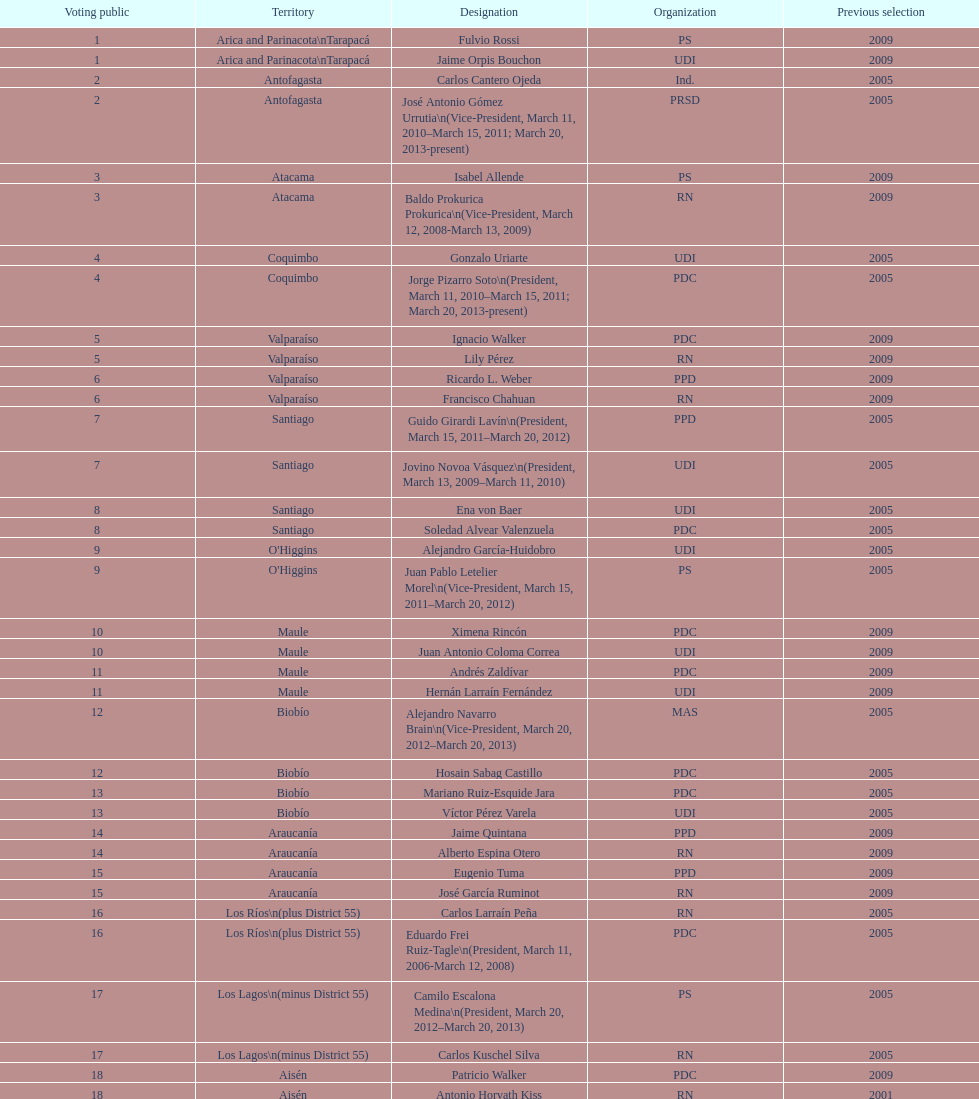When was antonio horvath kiss last elected? 2001. 